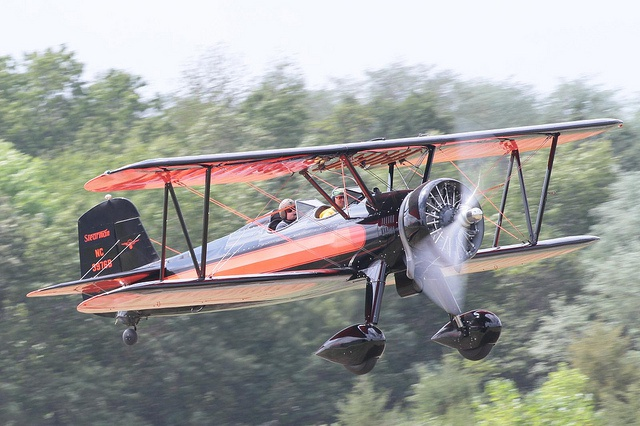Describe the objects in this image and their specific colors. I can see airplane in white, darkgray, gray, black, and lightpink tones, people in white, gray, lightgray, darkgray, and black tones, and people in white, ivory, brown, darkgray, and khaki tones in this image. 